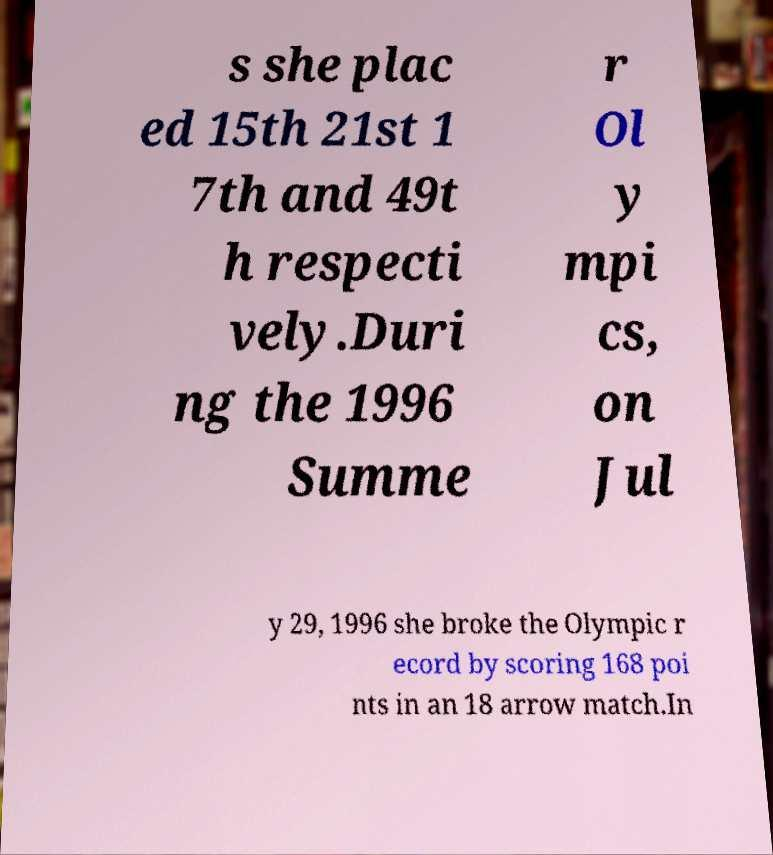There's text embedded in this image that I need extracted. Can you transcribe it verbatim? s she plac ed 15th 21st 1 7th and 49t h respecti vely.Duri ng the 1996 Summe r Ol y mpi cs, on Jul y 29, 1996 she broke the Olympic r ecord by scoring 168 poi nts in an 18 arrow match.In 